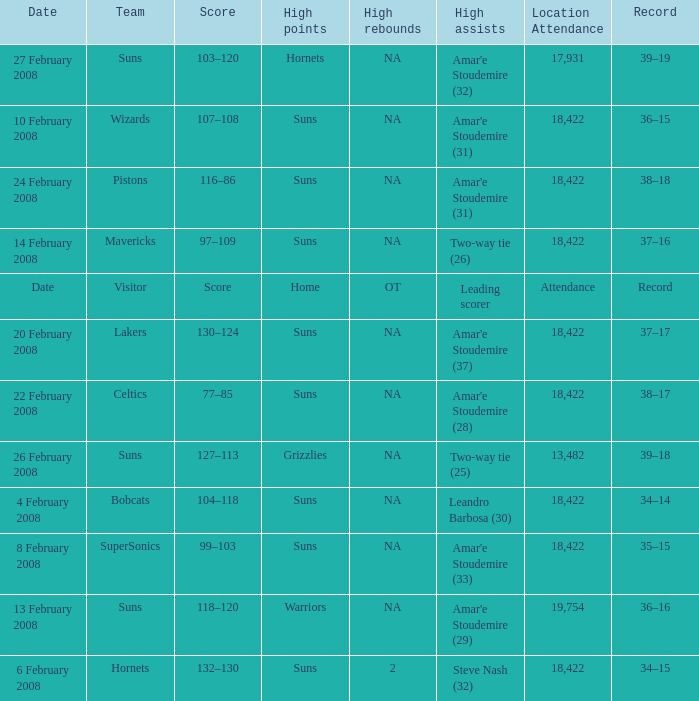How many high assists did the Lakers have? Amar'e Stoudemire (37). 